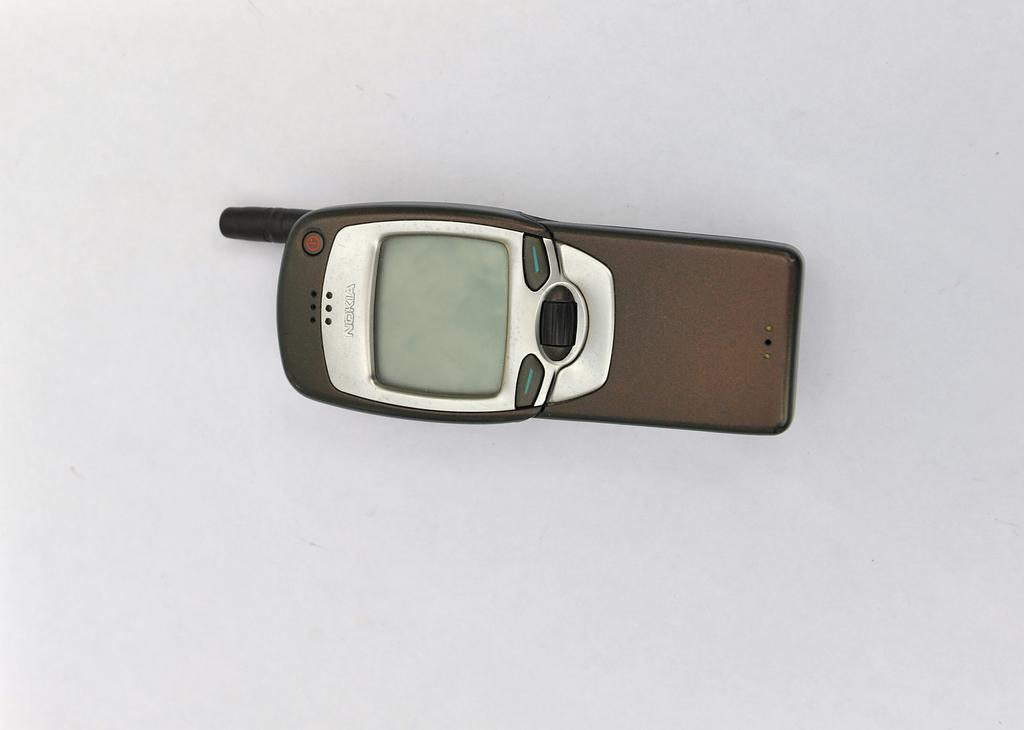Provide a one-sentence caption for the provided image. A brown Nokia cell phone sits powered off. 